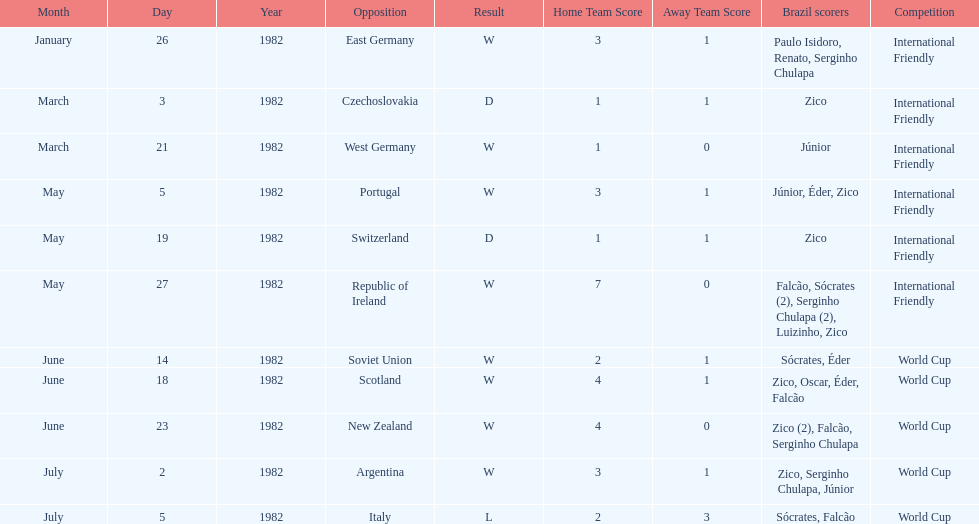How many times did brazil play west germany during the 1982 season? 1. 